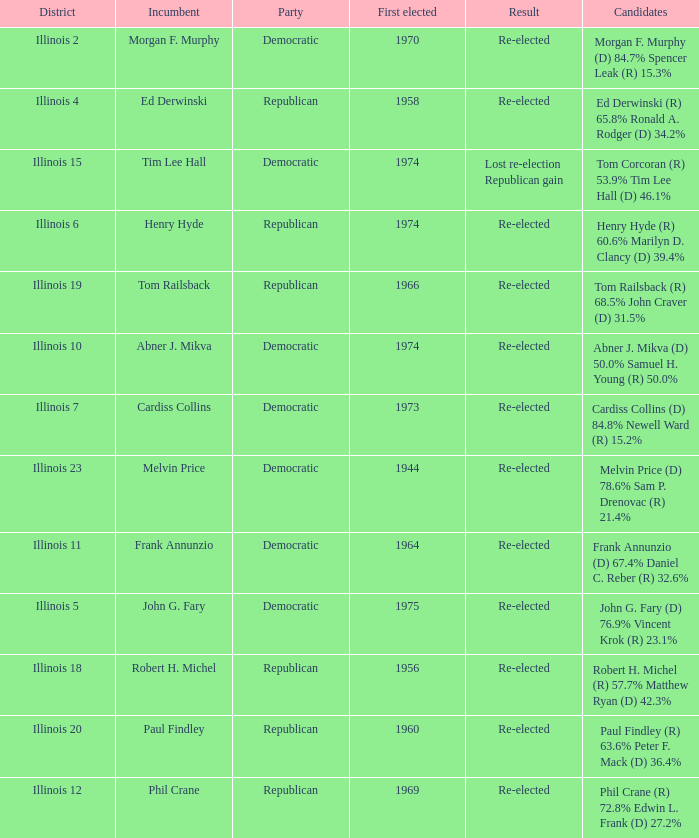Name the first elected for abner j. mikva 1974.0. 